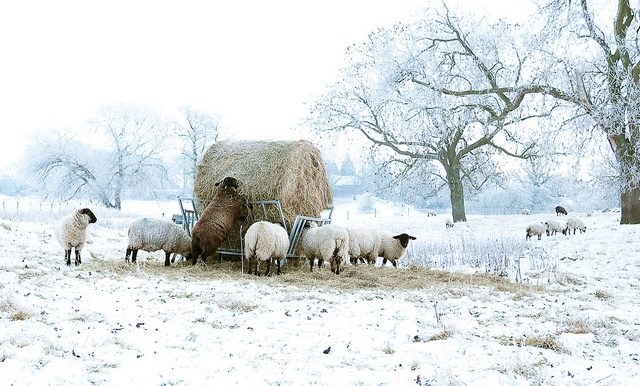Describe the objects in this image and their specific colors. I can see sheep in white, black, and gray tones, sheep in white, darkgray, lightgray, gray, and black tones, sheep in white, lightgray, darkgray, black, and gray tones, sheep in white, lightgray, darkgray, and black tones, and sheep in white, lightgray, darkgray, black, and gray tones in this image. 